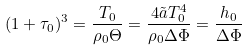Convert formula to latex. <formula><loc_0><loc_0><loc_500><loc_500>( 1 + \tau _ { 0 } ) ^ { 3 } = \frac { T _ { 0 } } { \rho _ { 0 } \Theta } = \frac { 4 \tilde { a } T _ { 0 } ^ { 4 } } { \rho _ { 0 } \Delta \Phi } = \frac { h _ { 0 } } { \Delta \Phi }</formula> 